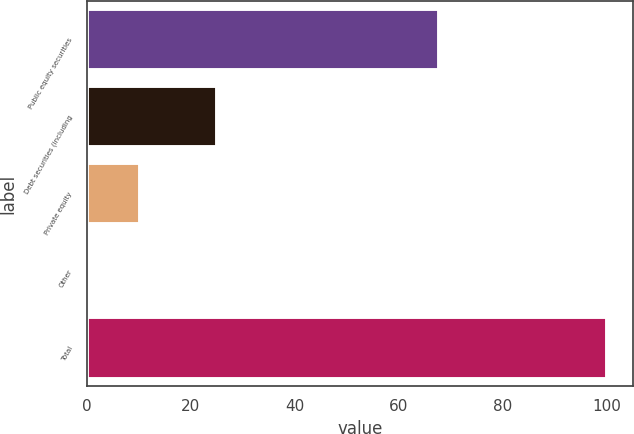<chart> <loc_0><loc_0><loc_500><loc_500><bar_chart><fcel>Public equity securities<fcel>Debt securities (including<fcel>Private equity<fcel>Other<fcel>Total<nl><fcel>67.7<fcel>25<fcel>10.18<fcel>0.2<fcel>100<nl></chart> 